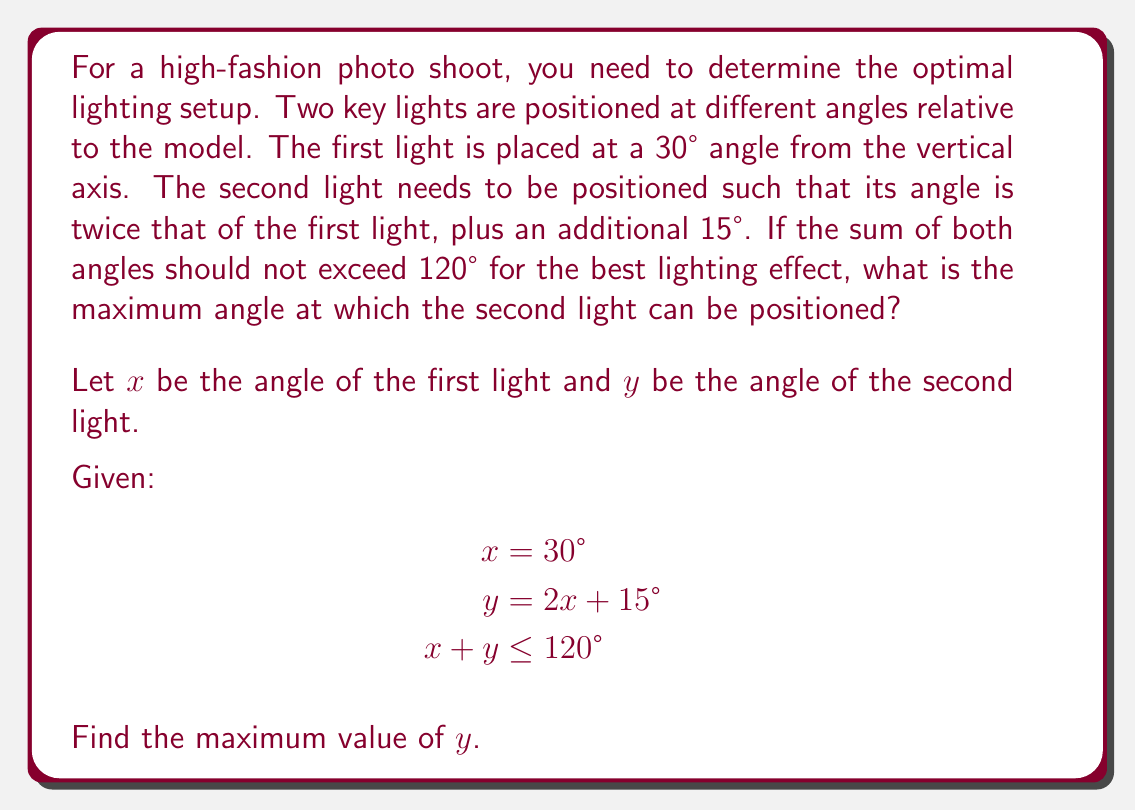Solve this math problem. To solve this problem, we'll use a system of equations approach:

1) We know that $x = 30°$, so we can substitute this into the equation for $y$:
   $$y = 2(30°) + 15° = 60° + 15° = 75°$$

2) Now we have two known values:
   $$x = 30°$$
   $$y = 75°$$

3) We need to check if these values satisfy the inequality $x + y \leq 120°$:
   $$30° + 75° = 105°$$
   $$105° \leq 120°$$

4) Since this inequality is satisfied, we know that 75° is a valid angle for the second light. However, we need to determine if this is the maximum possible angle.

5) To find the maximum angle, we can set the inequality to an equality:
   $$x + y = 120°$$

6) Substituting the known value of $x$:
   $$30° + y = 120°$$

7) Solving for $y$:
   $$y = 120° - 30° = 90°$$

8) Therefore, the maximum angle for the second light is 90°.

9) We need to verify if this satisfies the original equation for $y$:
   $$90° = 2(30°) + 15°$$
   $$90° = 60° + 15°$$
   $$90° = 75°$$

10) Since this equation is not satisfied (90° ≠ 75°), we conclude that the maximum angle for the second light is actually 75°, as calculated in step 1.
Answer: The maximum angle at which the second light can be positioned is 75°. 